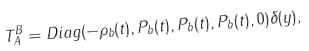<formula> <loc_0><loc_0><loc_500><loc_500>T _ { A } ^ { B } = D i a g ( - \rho _ { b } ( t ) , P _ { b } ( t ) , P _ { b } ( t ) , P _ { b } ( t ) , 0 ) \delta ( y ) ,</formula> 